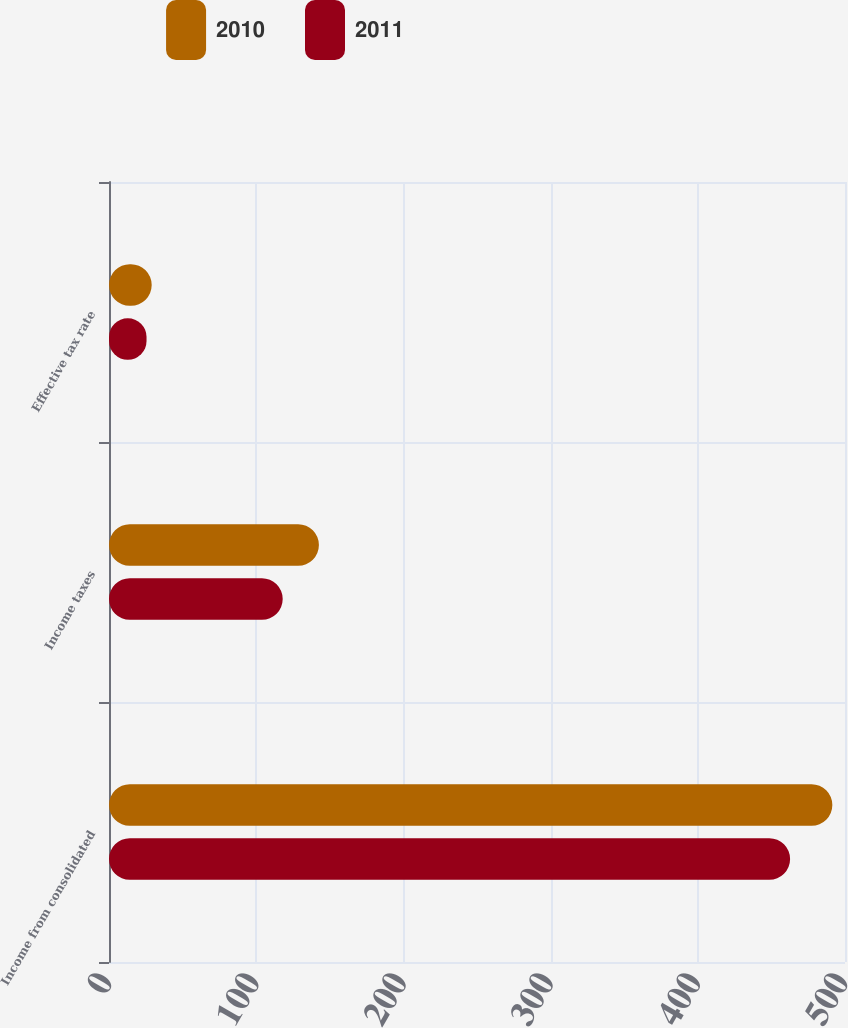<chart> <loc_0><loc_0><loc_500><loc_500><stacked_bar_chart><ecel><fcel>Income from consolidated<fcel>Income taxes<fcel>Effective tax rate<nl><fcel>2010<fcel>491.4<fcel>142.6<fcel>29<nl><fcel>2011<fcel>462.7<fcel>118<fcel>25.5<nl></chart> 